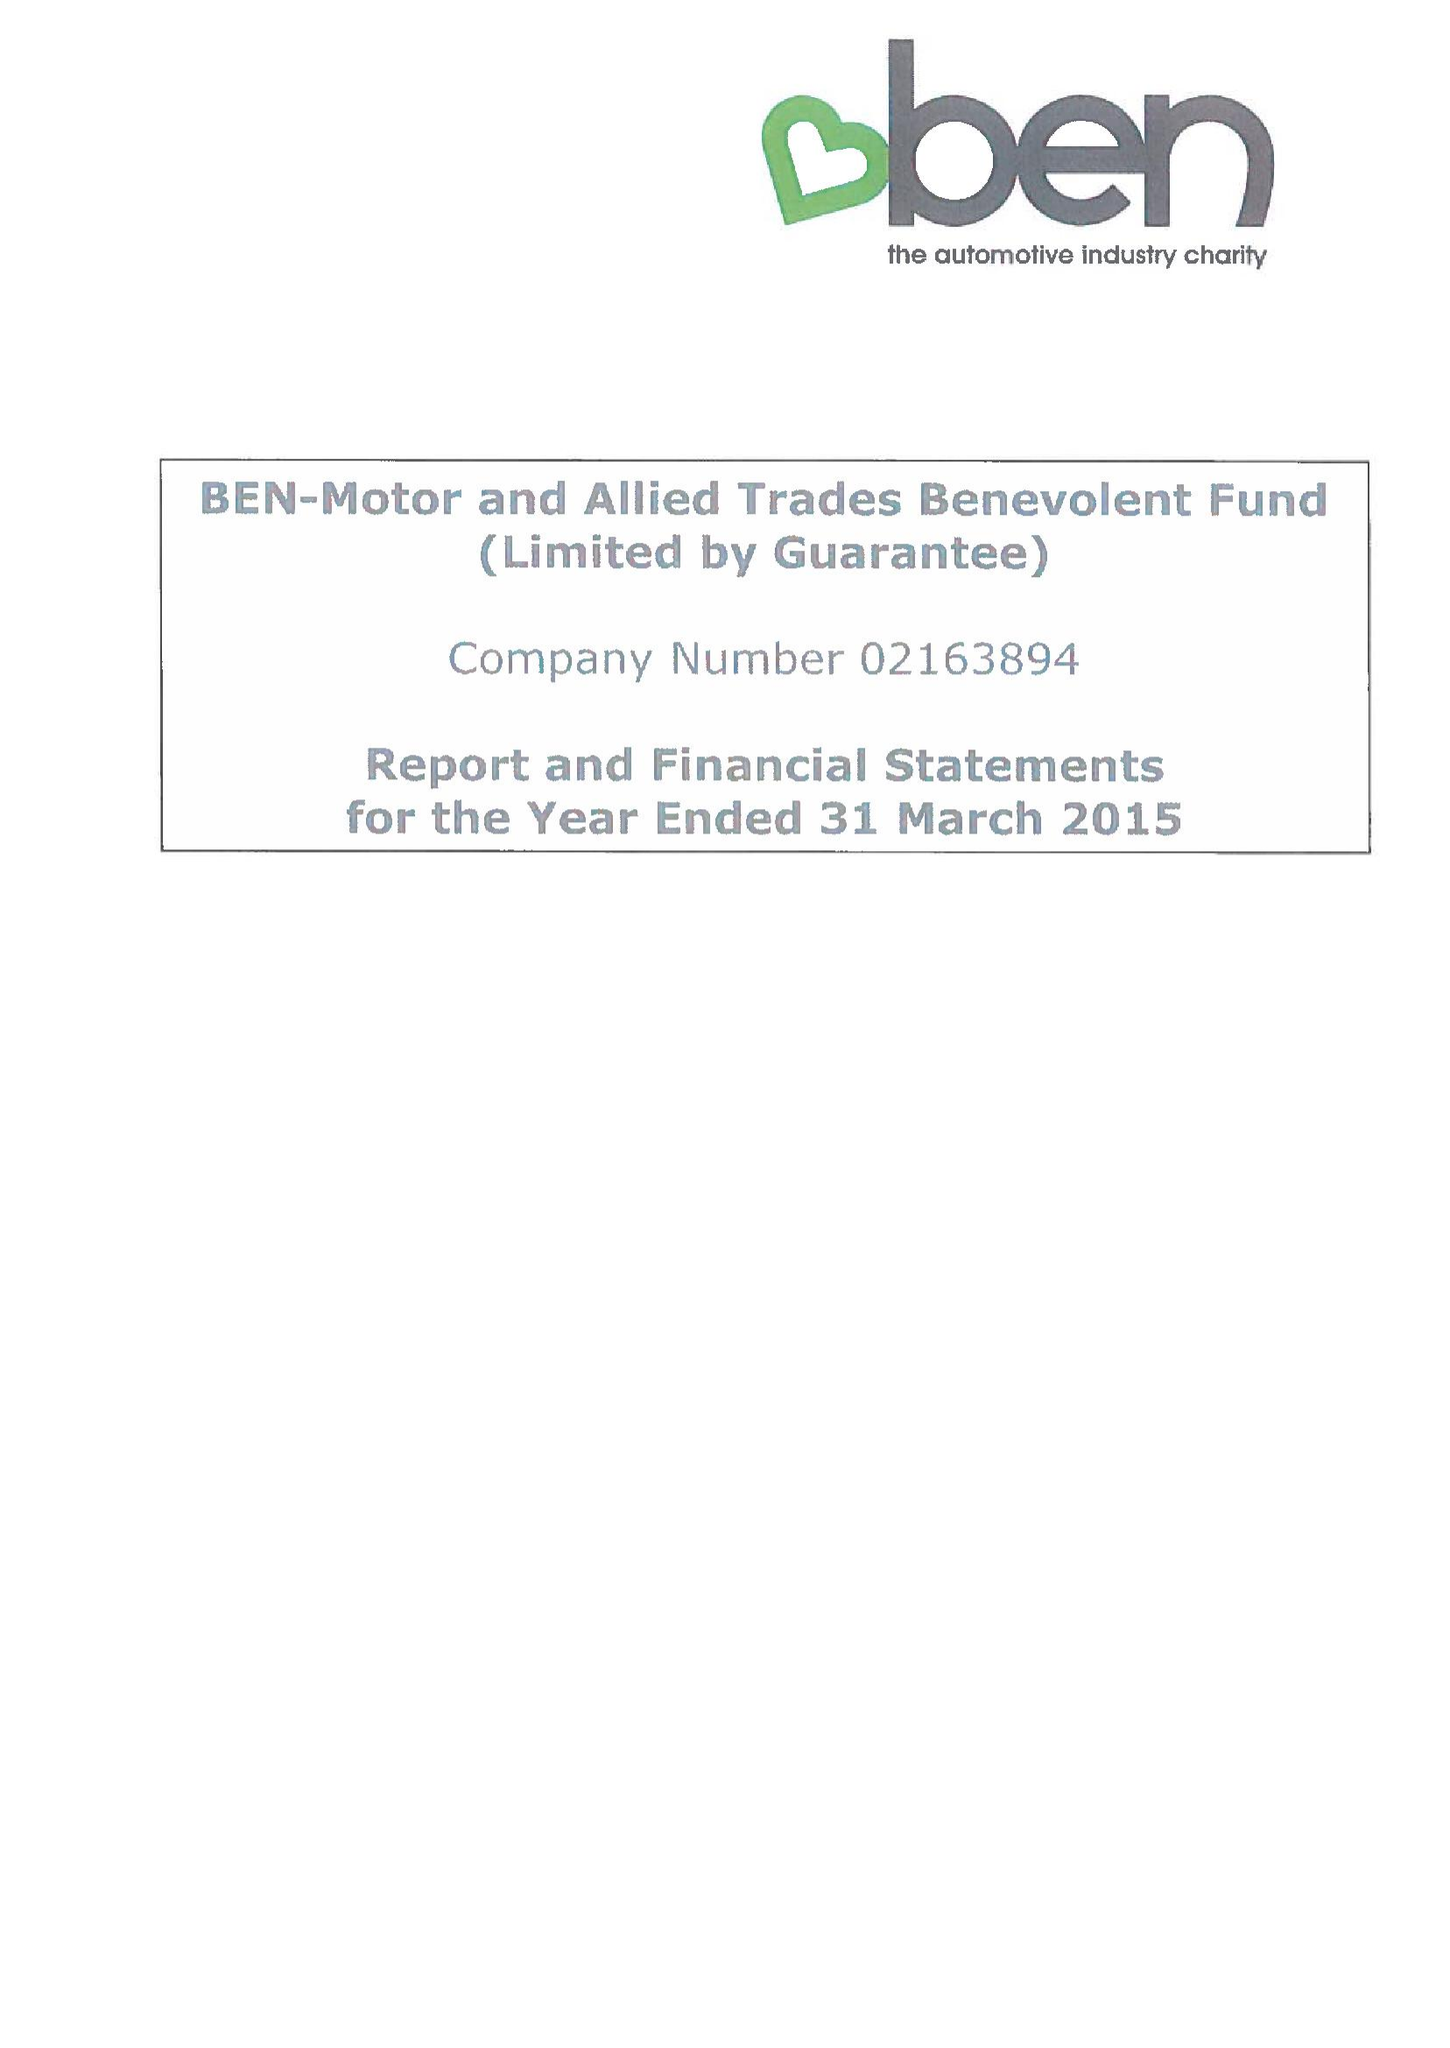What is the value for the report_date?
Answer the question using a single word or phrase. 2015-03-31 